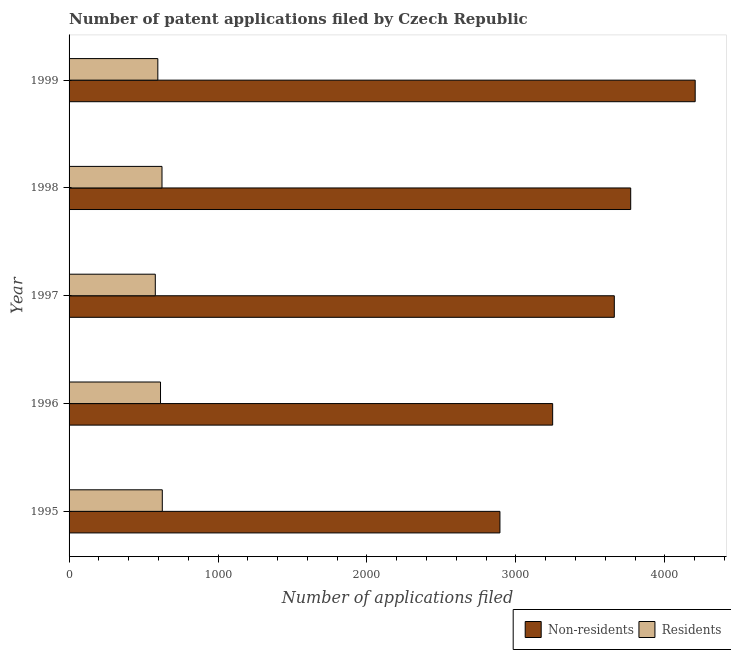How many bars are there on the 3rd tick from the bottom?
Provide a succinct answer. 2. What is the label of the 5th group of bars from the top?
Keep it short and to the point. 1995. What is the number of patent applications by non residents in 1997?
Make the answer very short. 3661. Across all years, what is the maximum number of patent applications by non residents?
Your answer should be compact. 4204. Across all years, what is the minimum number of patent applications by residents?
Your answer should be very brief. 579. In which year was the number of patent applications by residents maximum?
Ensure brevity in your answer.  1995. In which year was the number of patent applications by residents minimum?
Ensure brevity in your answer.  1997. What is the total number of patent applications by non residents in the graph?
Make the answer very short. 1.78e+04. What is the difference between the number of patent applications by residents in 1997 and that in 1999?
Offer a very short reply. -17. What is the difference between the number of patent applications by residents in 1996 and the number of patent applications by non residents in 1997?
Your answer should be compact. -3047. What is the average number of patent applications by non residents per year?
Your answer should be compact. 3555.2. In the year 1997, what is the difference between the number of patent applications by non residents and number of patent applications by residents?
Offer a terse response. 3082. Is the difference between the number of patent applications by non residents in 1995 and 1999 greater than the difference between the number of patent applications by residents in 1995 and 1999?
Make the answer very short. No. What is the difference between the highest and the lowest number of patent applications by non residents?
Make the answer very short. 1311. What does the 2nd bar from the top in 1999 represents?
Your response must be concise. Non-residents. What does the 1st bar from the bottom in 1995 represents?
Keep it short and to the point. Non-residents. How many bars are there?
Offer a terse response. 10. Where does the legend appear in the graph?
Offer a very short reply. Bottom right. How many legend labels are there?
Provide a succinct answer. 2. What is the title of the graph?
Make the answer very short. Number of patent applications filed by Czech Republic. What is the label or title of the X-axis?
Provide a succinct answer. Number of applications filed. What is the Number of applications filed of Non-residents in 1995?
Your answer should be very brief. 2893. What is the Number of applications filed of Residents in 1995?
Provide a succinct answer. 626. What is the Number of applications filed of Non-residents in 1996?
Your answer should be compact. 3247. What is the Number of applications filed of Residents in 1996?
Offer a terse response. 614. What is the Number of applications filed in Non-residents in 1997?
Provide a short and direct response. 3661. What is the Number of applications filed of Residents in 1997?
Offer a terse response. 579. What is the Number of applications filed in Non-residents in 1998?
Give a very brief answer. 3771. What is the Number of applications filed of Residents in 1998?
Provide a short and direct response. 624. What is the Number of applications filed of Non-residents in 1999?
Your response must be concise. 4204. What is the Number of applications filed in Residents in 1999?
Your response must be concise. 596. Across all years, what is the maximum Number of applications filed of Non-residents?
Ensure brevity in your answer.  4204. Across all years, what is the maximum Number of applications filed in Residents?
Provide a short and direct response. 626. Across all years, what is the minimum Number of applications filed in Non-residents?
Provide a succinct answer. 2893. Across all years, what is the minimum Number of applications filed of Residents?
Provide a short and direct response. 579. What is the total Number of applications filed of Non-residents in the graph?
Give a very brief answer. 1.78e+04. What is the total Number of applications filed of Residents in the graph?
Your answer should be very brief. 3039. What is the difference between the Number of applications filed in Non-residents in 1995 and that in 1996?
Provide a succinct answer. -354. What is the difference between the Number of applications filed of Residents in 1995 and that in 1996?
Make the answer very short. 12. What is the difference between the Number of applications filed of Non-residents in 1995 and that in 1997?
Your answer should be very brief. -768. What is the difference between the Number of applications filed in Residents in 1995 and that in 1997?
Provide a short and direct response. 47. What is the difference between the Number of applications filed in Non-residents in 1995 and that in 1998?
Offer a terse response. -878. What is the difference between the Number of applications filed in Non-residents in 1995 and that in 1999?
Your answer should be compact. -1311. What is the difference between the Number of applications filed in Non-residents in 1996 and that in 1997?
Make the answer very short. -414. What is the difference between the Number of applications filed of Residents in 1996 and that in 1997?
Provide a succinct answer. 35. What is the difference between the Number of applications filed of Non-residents in 1996 and that in 1998?
Your answer should be compact. -524. What is the difference between the Number of applications filed in Non-residents in 1996 and that in 1999?
Provide a succinct answer. -957. What is the difference between the Number of applications filed of Residents in 1996 and that in 1999?
Keep it short and to the point. 18. What is the difference between the Number of applications filed of Non-residents in 1997 and that in 1998?
Your response must be concise. -110. What is the difference between the Number of applications filed of Residents in 1997 and that in 1998?
Your response must be concise. -45. What is the difference between the Number of applications filed in Non-residents in 1997 and that in 1999?
Your answer should be compact. -543. What is the difference between the Number of applications filed of Residents in 1997 and that in 1999?
Provide a short and direct response. -17. What is the difference between the Number of applications filed in Non-residents in 1998 and that in 1999?
Offer a very short reply. -433. What is the difference between the Number of applications filed in Non-residents in 1995 and the Number of applications filed in Residents in 1996?
Provide a succinct answer. 2279. What is the difference between the Number of applications filed of Non-residents in 1995 and the Number of applications filed of Residents in 1997?
Offer a terse response. 2314. What is the difference between the Number of applications filed in Non-residents in 1995 and the Number of applications filed in Residents in 1998?
Keep it short and to the point. 2269. What is the difference between the Number of applications filed of Non-residents in 1995 and the Number of applications filed of Residents in 1999?
Your response must be concise. 2297. What is the difference between the Number of applications filed in Non-residents in 1996 and the Number of applications filed in Residents in 1997?
Keep it short and to the point. 2668. What is the difference between the Number of applications filed in Non-residents in 1996 and the Number of applications filed in Residents in 1998?
Ensure brevity in your answer.  2623. What is the difference between the Number of applications filed in Non-residents in 1996 and the Number of applications filed in Residents in 1999?
Provide a short and direct response. 2651. What is the difference between the Number of applications filed in Non-residents in 1997 and the Number of applications filed in Residents in 1998?
Your response must be concise. 3037. What is the difference between the Number of applications filed in Non-residents in 1997 and the Number of applications filed in Residents in 1999?
Make the answer very short. 3065. What is the difference between the Number of applications filed of Non-residents in 1998 and the Number of applications filed of Residents in 1999?
Your answer should be compact. 3175. What is the average Number of applications filed in Non-residents per year?
Offer a terse response. 3555.2. What is the average Number of applications filed of Residents per year?
Make the answer very short. 607.8. In the year 1995, what is the difference between the Number of applications filed in Non-residents and Number of applications filed in Residents?
Make the answer very short. 2267. In the year 1996, what is the difference between the Number of applications filed in Non-residents and Number of applications filed in Residents?
Offer a very short reply. 2633. In the year 1997, what is the difference between the Number of applications filed in Non-residents and Number of applications filed in Residents?
Keep it short and to the point. 3082. In the year 1998, what is the difference between the Number of applications filed of Non-residents and Number of applications filed of Residents?
Offer a terse response. 3147. In the year 1999, what is the difference between the Number of applications filed of Non-residents and Number of applications filed of Residents?
Offer a terse response. 3608. What is the ratio of the Number of applications filed in Non-residents in 1995 to that in 1996?
Your response must be concise. 0.89. What is the ratio of the Number of applications filed in Residents in 1995 to that in 1996?
Offer a terse response. 1.02. What is the ratio of the Number of applications filed of Non-residents in 1995 to that in 1997?
Keep it short and to the point. 0.79. What is the ratio of the Number of applications filed of Residents in 1995 to that in 1997?
Your answer should be compact. 1.08. What is the ratio of the Number of applications filed in Non-residents in 1995 to that in 1998?
Your answer should be compact. 0.77. What is the ratio of the Number of applications filed of Residents in 1995 to that in 1998?
Offer a very short reply. 1. What is the ratio of the Number of applications filed of Non-residents in 1995 to that in 1999?
Offer a terse response. 0.69. What is the ratio of the Number of applications filed of Residents in 1995 to that in 1999?
Ensure brevity in your answer.  1.05. What is the ratio of the Number of applications filed in Non-residents in 1996 to that in 1997?
Make the answer very short. 0.89. What is the ratio of the Number of applications filed in Residents in 1996 to that in 1997?
Provide a short and direct response. 1.06. What is the ratio of the Number of applications filed in Non-residents in 1996 to that in 1998?
Ensure brevity in your answer.  0.86. What is the ratio of the Number of applications filed in Non-residents in 1996 to that in 1999?
Make the answer very short. 0.77. What is the ratio of the Number of applications filed in Residents in 1996 to that in 1999?
Offer a terse response. 1.03. What is the ratio of the Number of applications filed of Non-residents in 1997 to that in 1998?
Make the answer very short. 0.97. What is the ratio of the Number of applications filed of Residents in 1997 to that in 1998?
Ensure brevity in your answer.  0.93. What is the ratio of the Number of applications filed in Non-residents in 1997 to that in 1999?
Provide a succinct answer. 0.87. What is the ratio of the Number of applications filed in Residents in 1997 to that in 1999?
Give a very brief answer. 0.97. What is the ratio of the Number of applications filed in Non-residents in 1998 to that in 1999?
Offer a very short reply. 0.9. What is the ratio of the Number of applications filed in Residents in 1998 to that in 1999?
Offer a terse response. 1.05. What is the difference between the highest and the second highest Number of applications filed of Non-residents?
Offer a very short reply. 433. What is the difference between the highest and the lowest Number of applications filed of Non-residents?
Make the answer very short. 1311. 